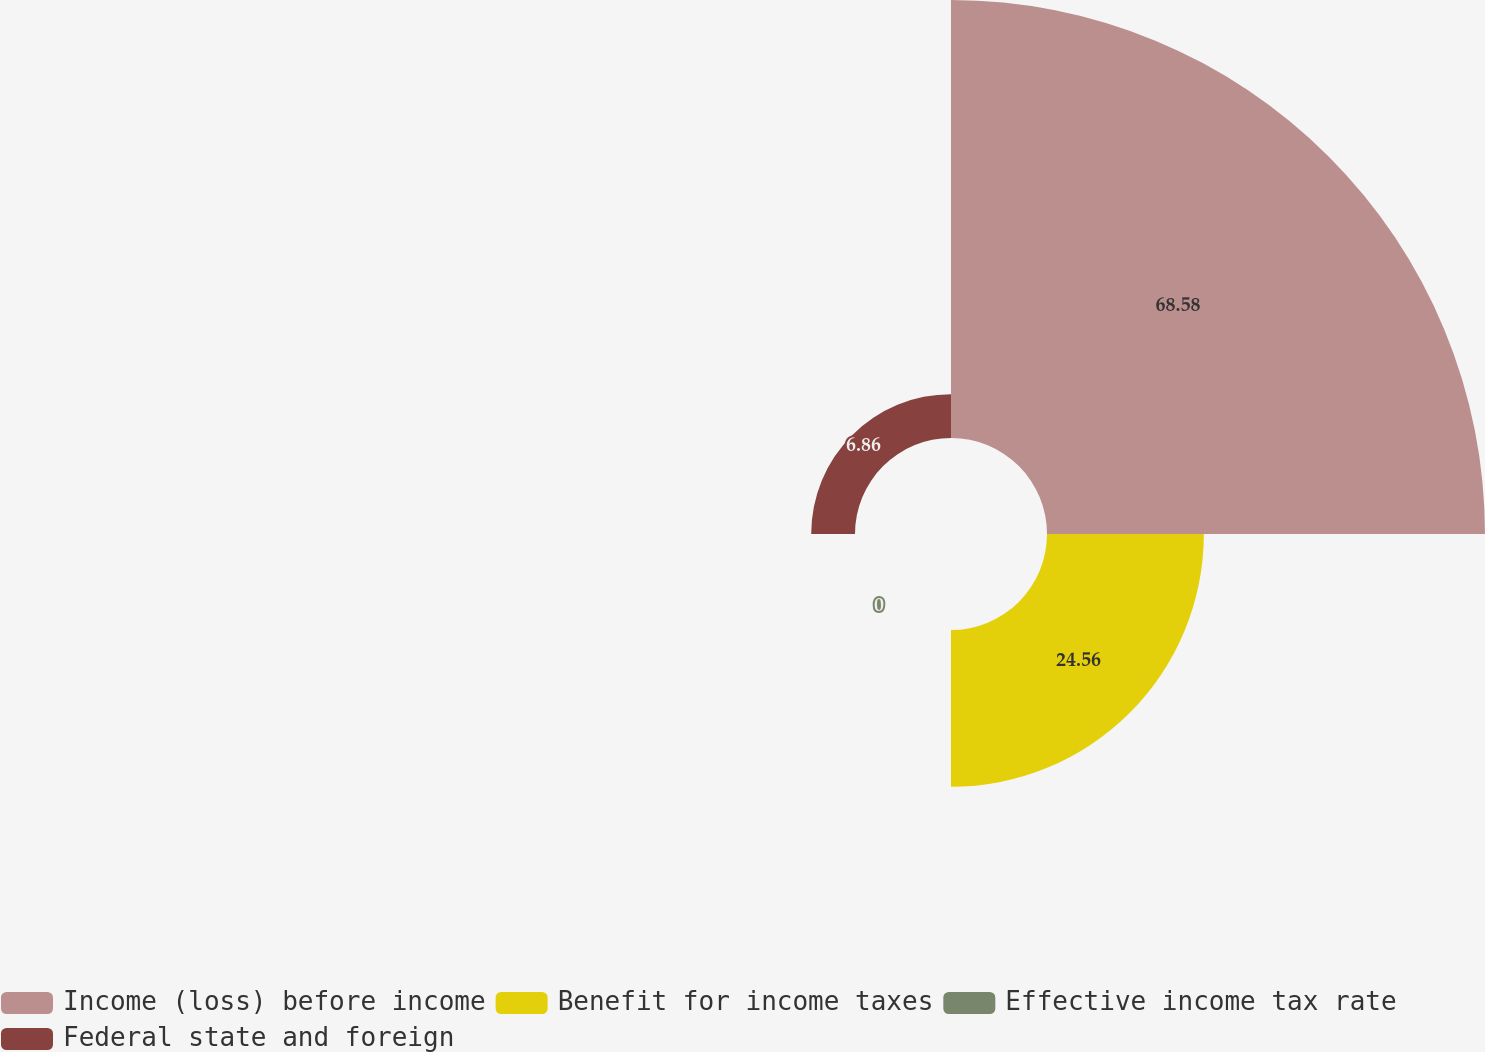<chart> <loc_0><loc_0><loc_500><loc_500><pie_chart><fcel>Income (loss) before income<fcel>Benefit for income taxes<fcel>Effective income tax rate<fcel>Federal state and foreign<nl><fcel>68.58%<fcel>24.56%<fcel>0.0%<fcel>6.86%<nl></chart> 